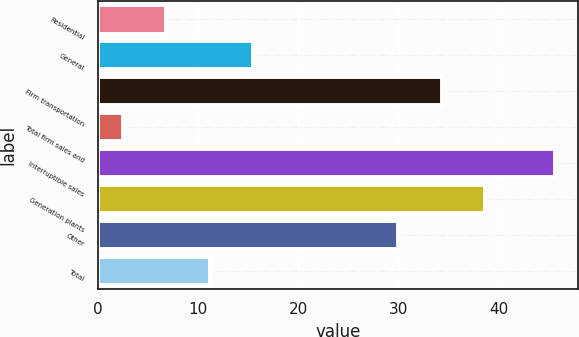<chart> <loc_0><loc_0><loc_500><loc_500><bar_chart><fcel>Residential<fcel>General<fcel>Firm transportation<fcel>Total firm sales and<fcel>Interruptible sales<fcel>Generation plants<fcel>Other<fcel>Total<nl><fcel>6.82<fcel>15.46<fcel>34.32<fcel>2.5<fcel>45.7<fcel>38.64<fcel>30<fcel>11.14<nl></chart> 